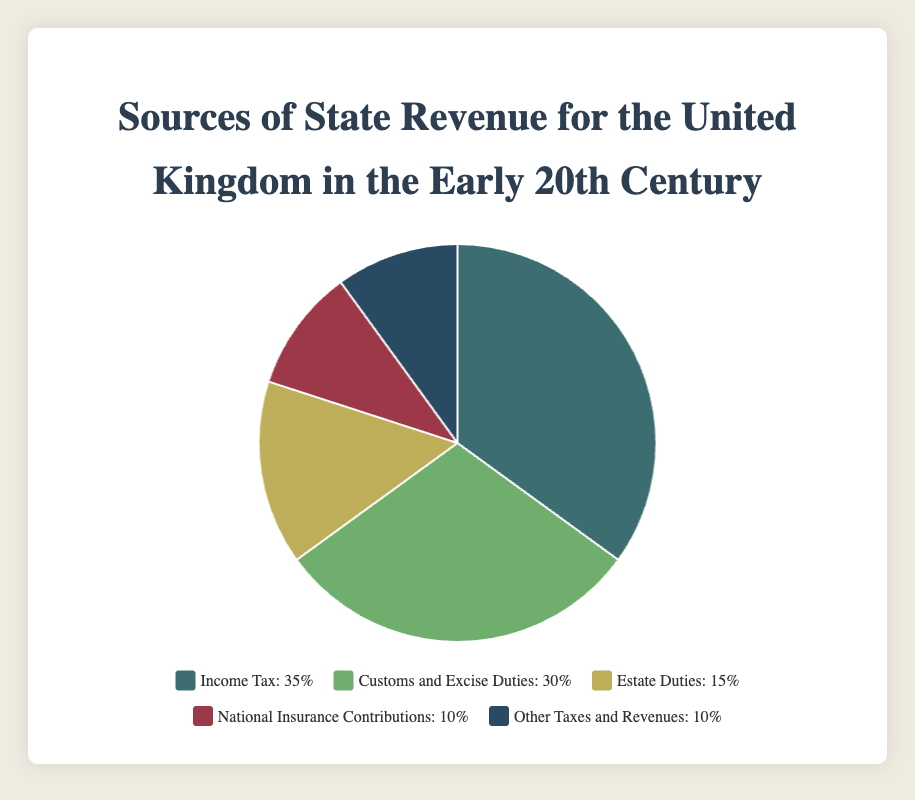What is the largest source of state revenue for the UK in the early 20th century? By looking at the pie chart, we can see that the section labeled 'Income Tax' is the largest, representing 35% of the total state revenue.
Answer: Income Tax Which revenue source contributes more, Customs and Excise Duties or Estate Duties? By comparing the two sections, we see that Customs and Excise Duties contribute 30%, while Estate Duties contribute 15%. Thus, Customs and Excise Duties contribute more.
Answer: Customs and Excise Duties How much more does Income Tax contribute to the total revenue compared to National Insurance Contributions? Income Tax contributes 35%, and National Insurance Contributions account for 10%. The difference is 35% - 10% = 25%.
Answer: 25% What two sources combined make up 45% of the total state revenue? Adding the percentages for Estate Duties (15%) and both National Insurance Contributions (10%) and Other Taxes and Revenues (10%), we get 15% + 10% + 10% = 35%. Therefore, we must combine Income Tax (35%) and any of the other lower values, e.g., National Insurance Contributions (10%), totaling 45%.
Answer: Income Tax and National Insurance Contributions Which sources of revenue each contribute 10% to the total state revenue? By observing the pie chart, National Insurance Contributions and Other Taxes and Revenues each contribute 10%.
Answer: National Insurance Contributions and Other Taxes and Revenues What percentage of the total state revenue is contributed by sources other than Income Tax? To find the percentage of revenue from sources other than Income Tax, we subtract the percentage contributed by Income Tax (35%) from 100%. Thus, 100% - 35% = 65%.
Answer: 65% What is the second-largest source of state revenue? The second largest source can be identified by finding the section with the second highest percentage. Customs and Excise Duties contribute 30%, which is the second largest after Income Tax (35%).
Answer: Customs and Excise Duties If National Insurance Contributions were doubled, what would their new percentage be, and how would that affect the total percentage of Other Taxes and Revenues combined? Doubling the National Insurance Contributions from 10% would make it 20%. Adding the remaining Other Taxes and Revenues (10%), the total would then be 20% + 10% = 30%.
Answer: National Insurance Contributions would be 20%, and the combined total would be 30% What is the combined percentage of the three smallest sources of revenue? The three smallest sources are Estate Duties (15%), National Insurance Contributions (10%), and Other Taxes and Revenues (10%). Adding these, 15% + 10% + 10% = 35%.
Answer: 35% 